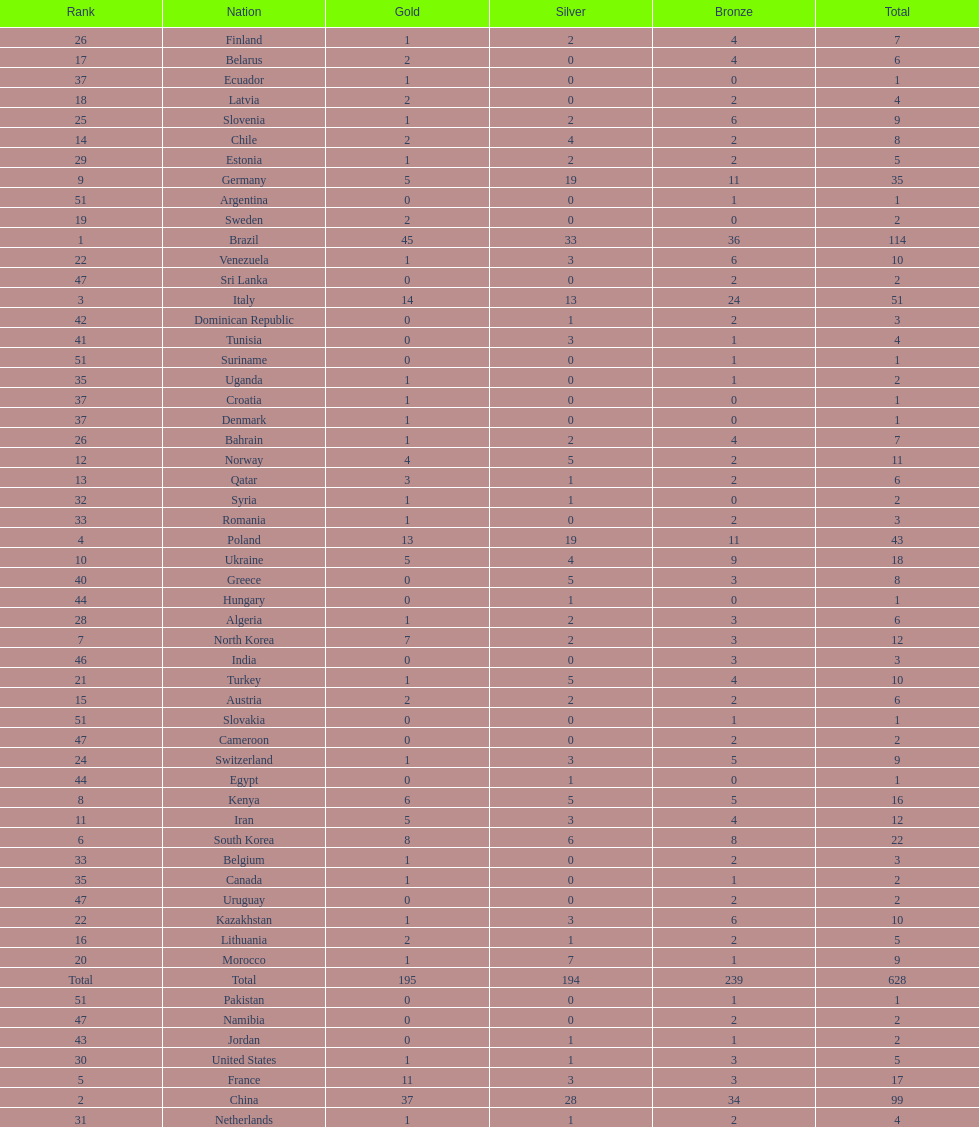How many total medals did norway win? 11. 